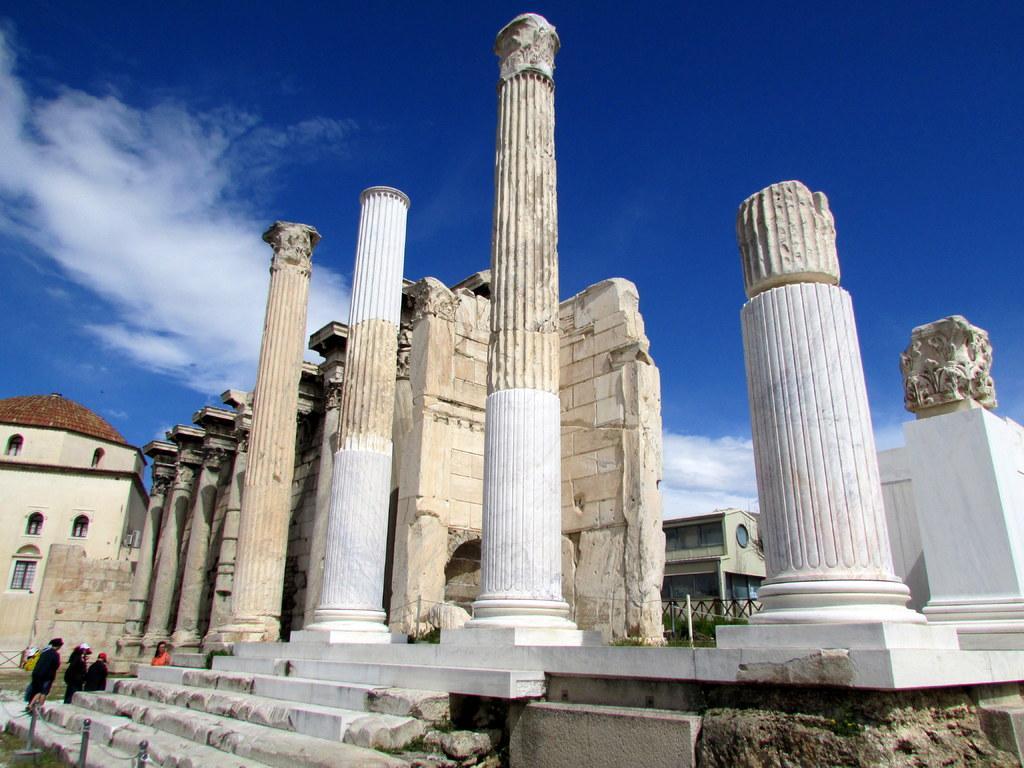Describe this image in one or two sentences. In this picture, we see the pillars and a castle. On the right side, we see a stone carved statue on the pillar. In the left bottom, we see the staircase, grass and the barrier poles. There are buildings and pillars in the background. At the top, we see the clouds and the sky, which is blue in color. 